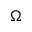Convert formula to latex. <formula><loc_0><loc_0><loc_500><loc_500>\Omega</formula> 